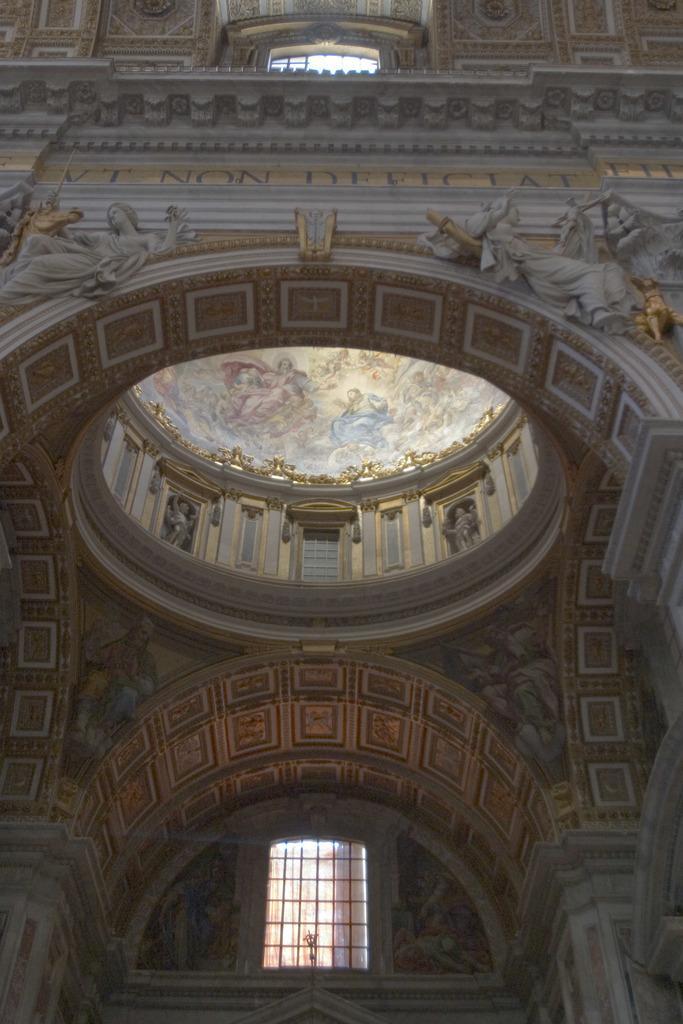Can you describe this image briefly? In this image we can see some historical monument. 